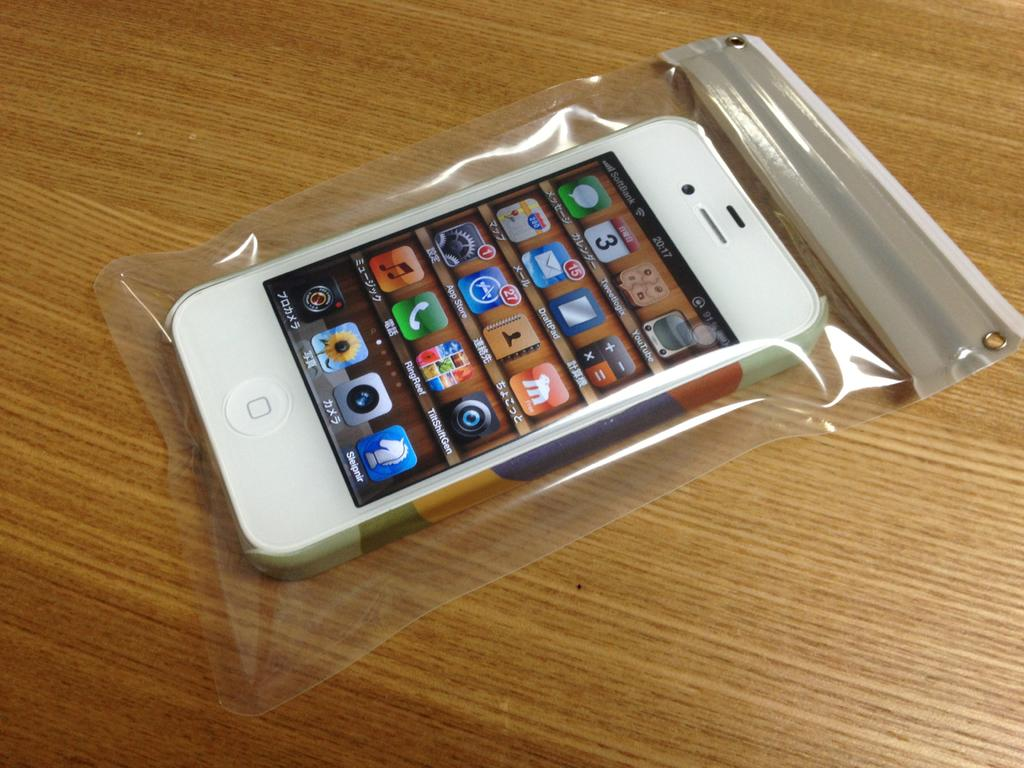<image>
Provide a brief description of the given image. A cell phone displays apps a the time of 20:17. 